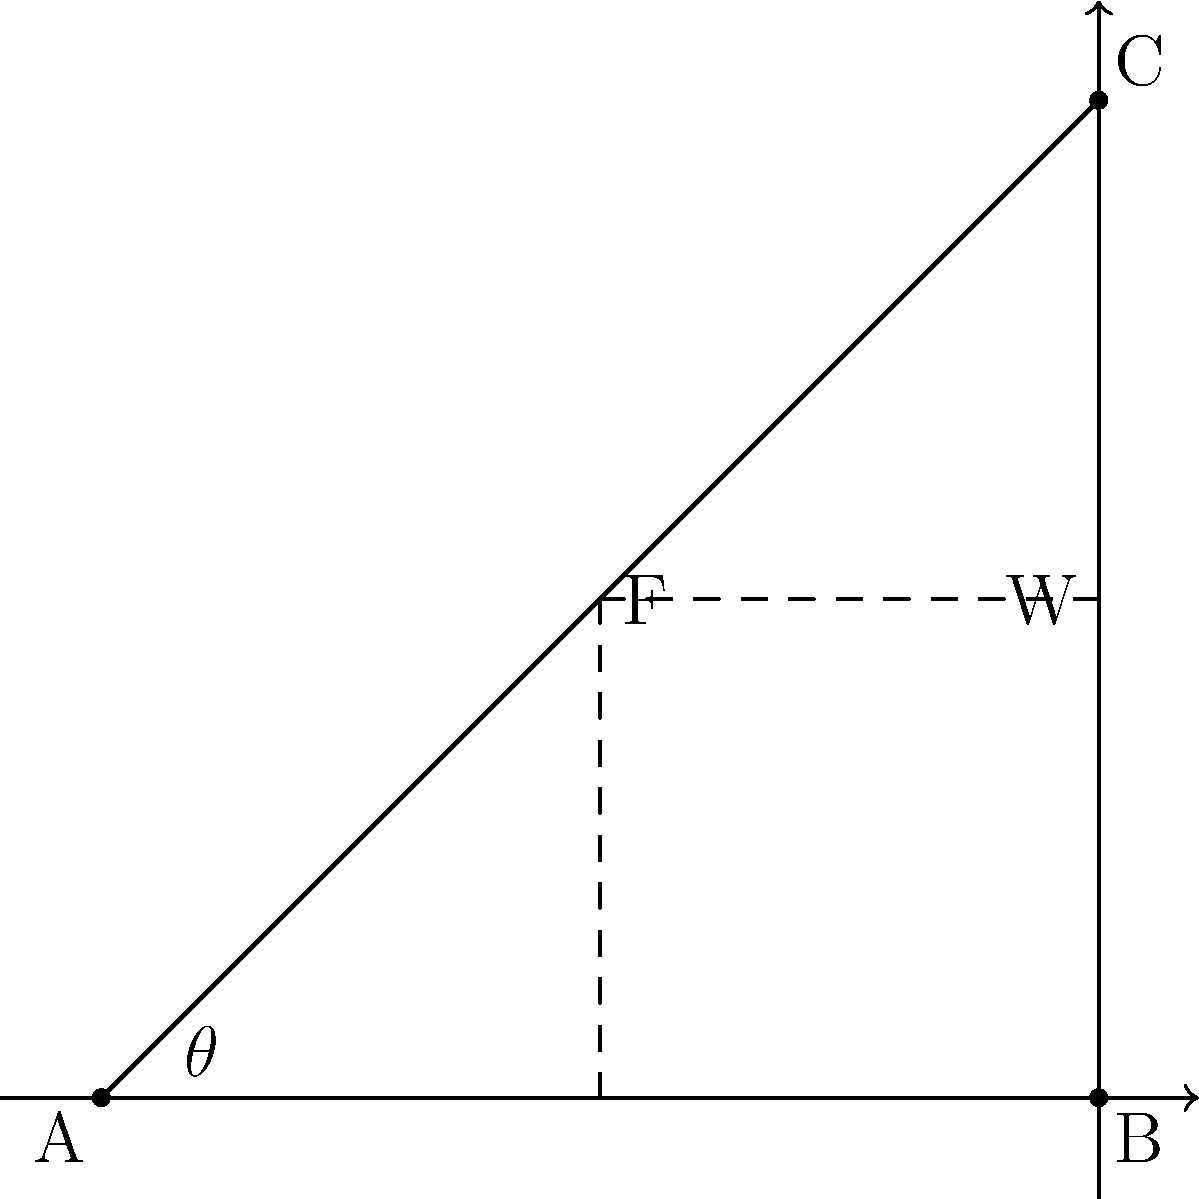A heavy mining drill weighing 5000 N needs to be lifted using a pulley system. The pulley is attached to a support beam at a 30-degree angle from the vertical. Calculate the force F required to lift the drill, assuming the system is in equilibrium and neglecting the weight of the rope and friction in the pulley. To solve this problem, we'll use the principle of force equilibrium and trigonometry. Here's a step-by-step solution:

1) In equilibrium, the sum of forces in both x and y directions must be zero.

2) Let's define our coordinate system:
   - y-axis: vertical (up is positive)
   - x-axis: horizontal (right is positive)

3) We have two forces:
   - W: Weight of the drill (5000 N), acting downwards
   - F: Force applied through the pulley, acting at a 30° angle from the vertical

4) Resolve force F into its x and y components:
   - $F_y = F \cos(30°)$
   - $F_x = F \sin(30°)$

5) For equilibrium in the y-direction:
   $F_y - W = 0$
   $F \cos(30°) - 5000 = 0$

6) Solve for F:
   $F \cos(30°) = 5000$
   $F = 5000 / \cos(30°)$

7) $\cos(30°) = \frac{\sqrt{3}}{2}$, so:
   $F = 5000 / (\frac{\sqrt{3}}{2}) = 5000 \cdot \frac{2}{\sqrt{3}} = \frac{10000}{\sqrt{3}}$

8) Simplify:
   $F = 5773.5$ N (rounded to one decimal place)

Therefore, a force of approximately 5773.5 N is required to lift the drill.
Answer: 5773.5 N 